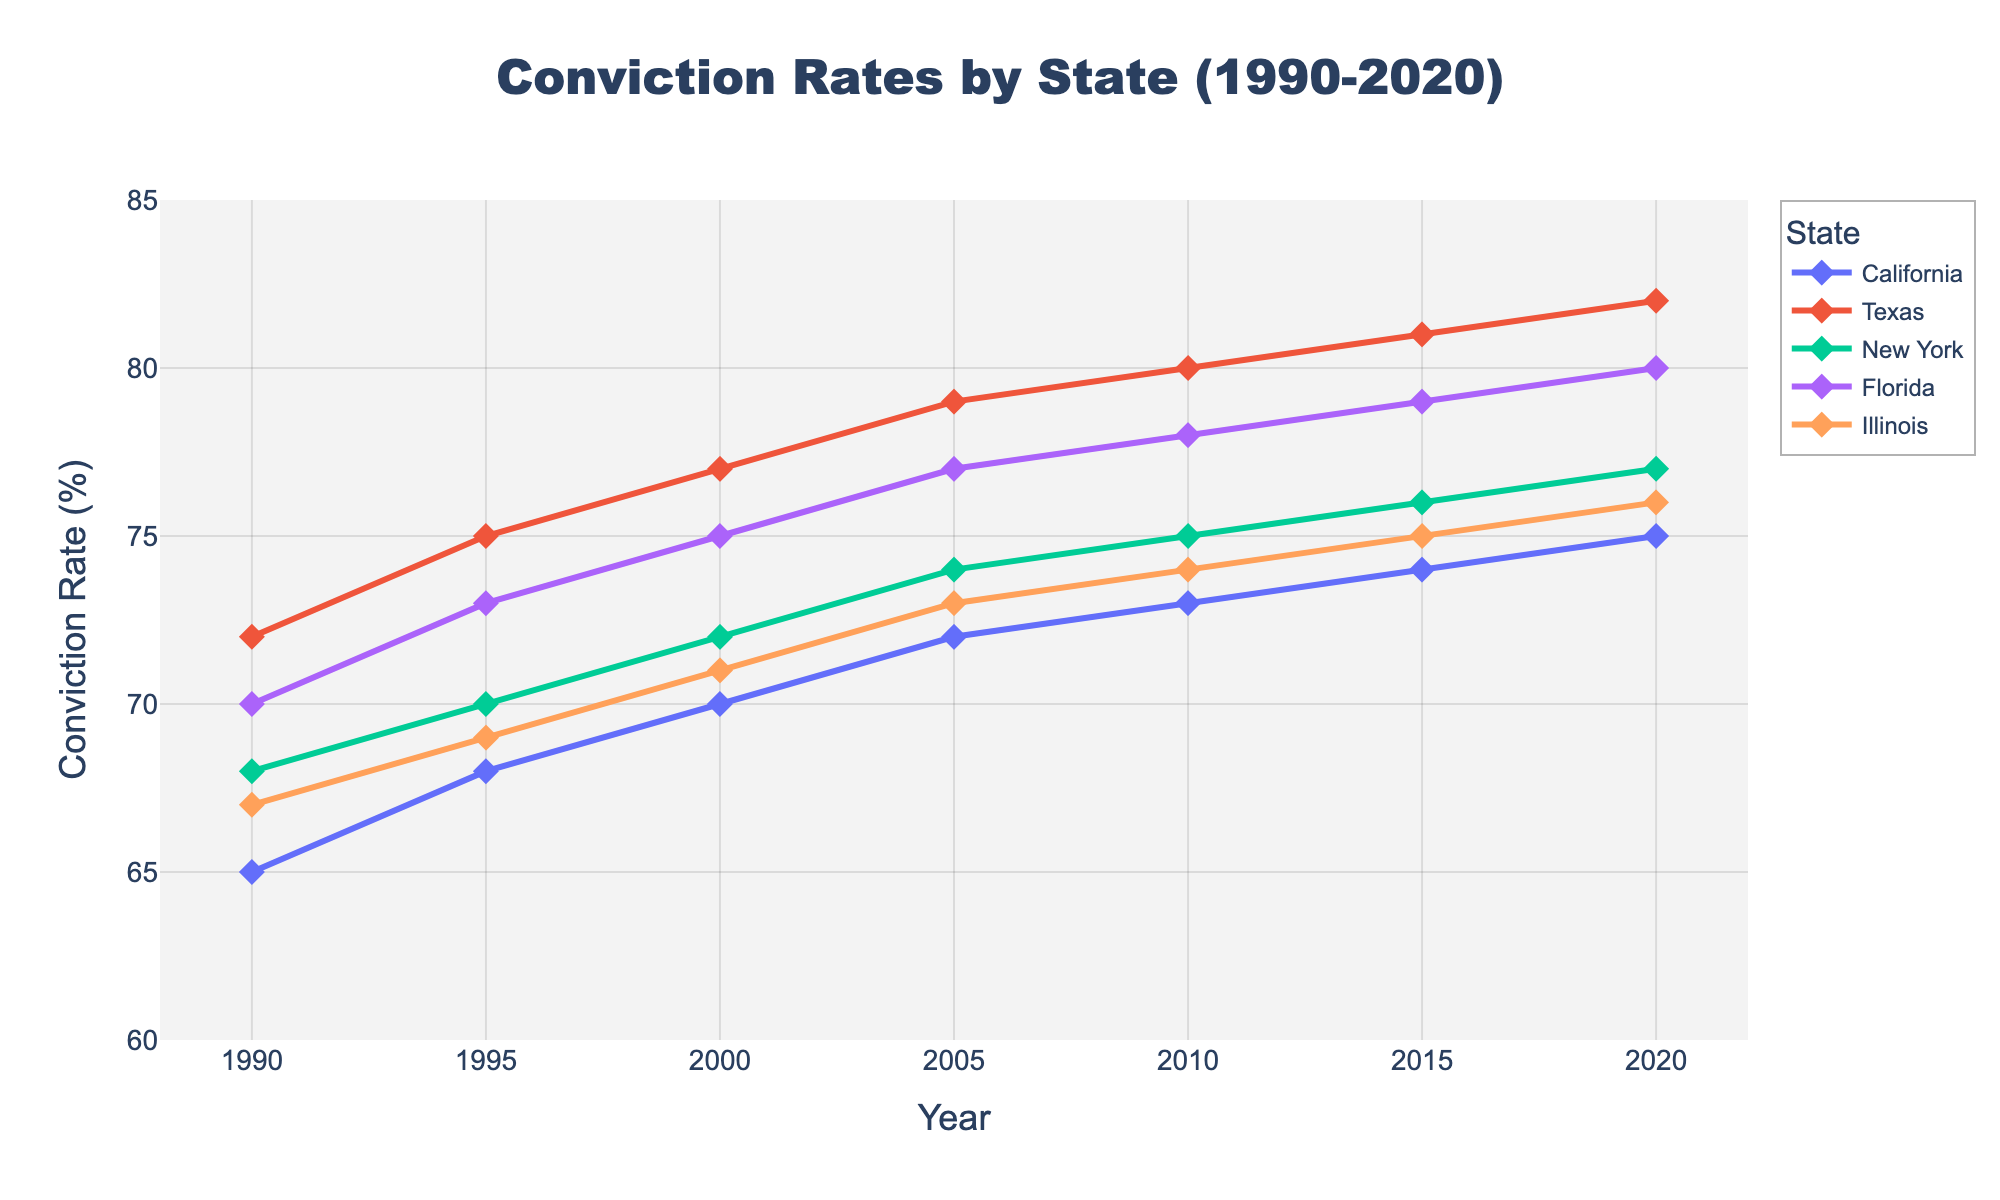What's the average conviction rate for California over the 30-year period? To find the average conviction rate, sum the rates for California in each year and divide by the number of years. (65 + 68 + 70 + 72 + 73 + 74 + 75) = 497, and there are 7 years: 497 / 7 = 71
Answer: 71 Which state had the highest conviction rate in 2020? In 2020, the conviction rates for the states are: California: 75, Texas: 82, New York: 77, Florida: 80, Illinois: 76. Texas has the highest rate.
Answer: Texas Did Illinois' conviction rate increase or decrease from 1990 to 2020? The conviction rate for Illinois in 1990 was 67, and in 2020 it was 76. Since 76 is higher than 67, it increased.
Answer: Increased Which state showed the greatest increase in conviction rates from 1990 to 2020? Calculate the difference in conviction rates from 1990 to 2020 for each state: California: 75 - 65 = 10, Texas: 82 - 72 = 10, New York: 77 - 68 = 9, Florida: 80 - 70 = 10, Illinois: 76 - 67 = 9. There is a tie for the greatest increase between California, Texas, and Florida, each with an increase of 10 percentage points.
Answer: California, Texas, and Florida What is the median conviction rate for New York across the years provided? To find the median, list the conviction rates for New York in ascending order and find the middle value: (68, 70, 72, 74, 75, 76, 77). The middle value is the 4th one, which is 74.
Answer: 74 In which year did Florida surpass the 75% conviction rate threshold? To determine this, look at Florida's conviction rate for each year: 1990: 70, 1995: 73, 2000: 75, 2005: 77, 2010: 78, 2015: 79, 2020: 80. Florida surpassed 75% in the year 2005.
Answer: 2005 Which state had the least change in conviction rates over the period? Calculate the change in conviction rates from 1990 to 2020 for each state: California: 10, Texas: 10, New York: 9, Florida: 10, Illinois: 9. The states with the least change are New York and Illinois, each with a 9 percentage point change.
Answer: New York and Illinois Did any state's conviction rate decrease in any of the given periods? Observing the conviction rates for all states over the years, none of the states show a decrease between consecutive periods; they all either increase or stay the same.
Answer: No What is the overall trend for conviction rates across all states from 1990 to 2020? All the states show an increasing trend in their conviction rates from 1990 to 2020 without any decreases.
Answer: Increasing 